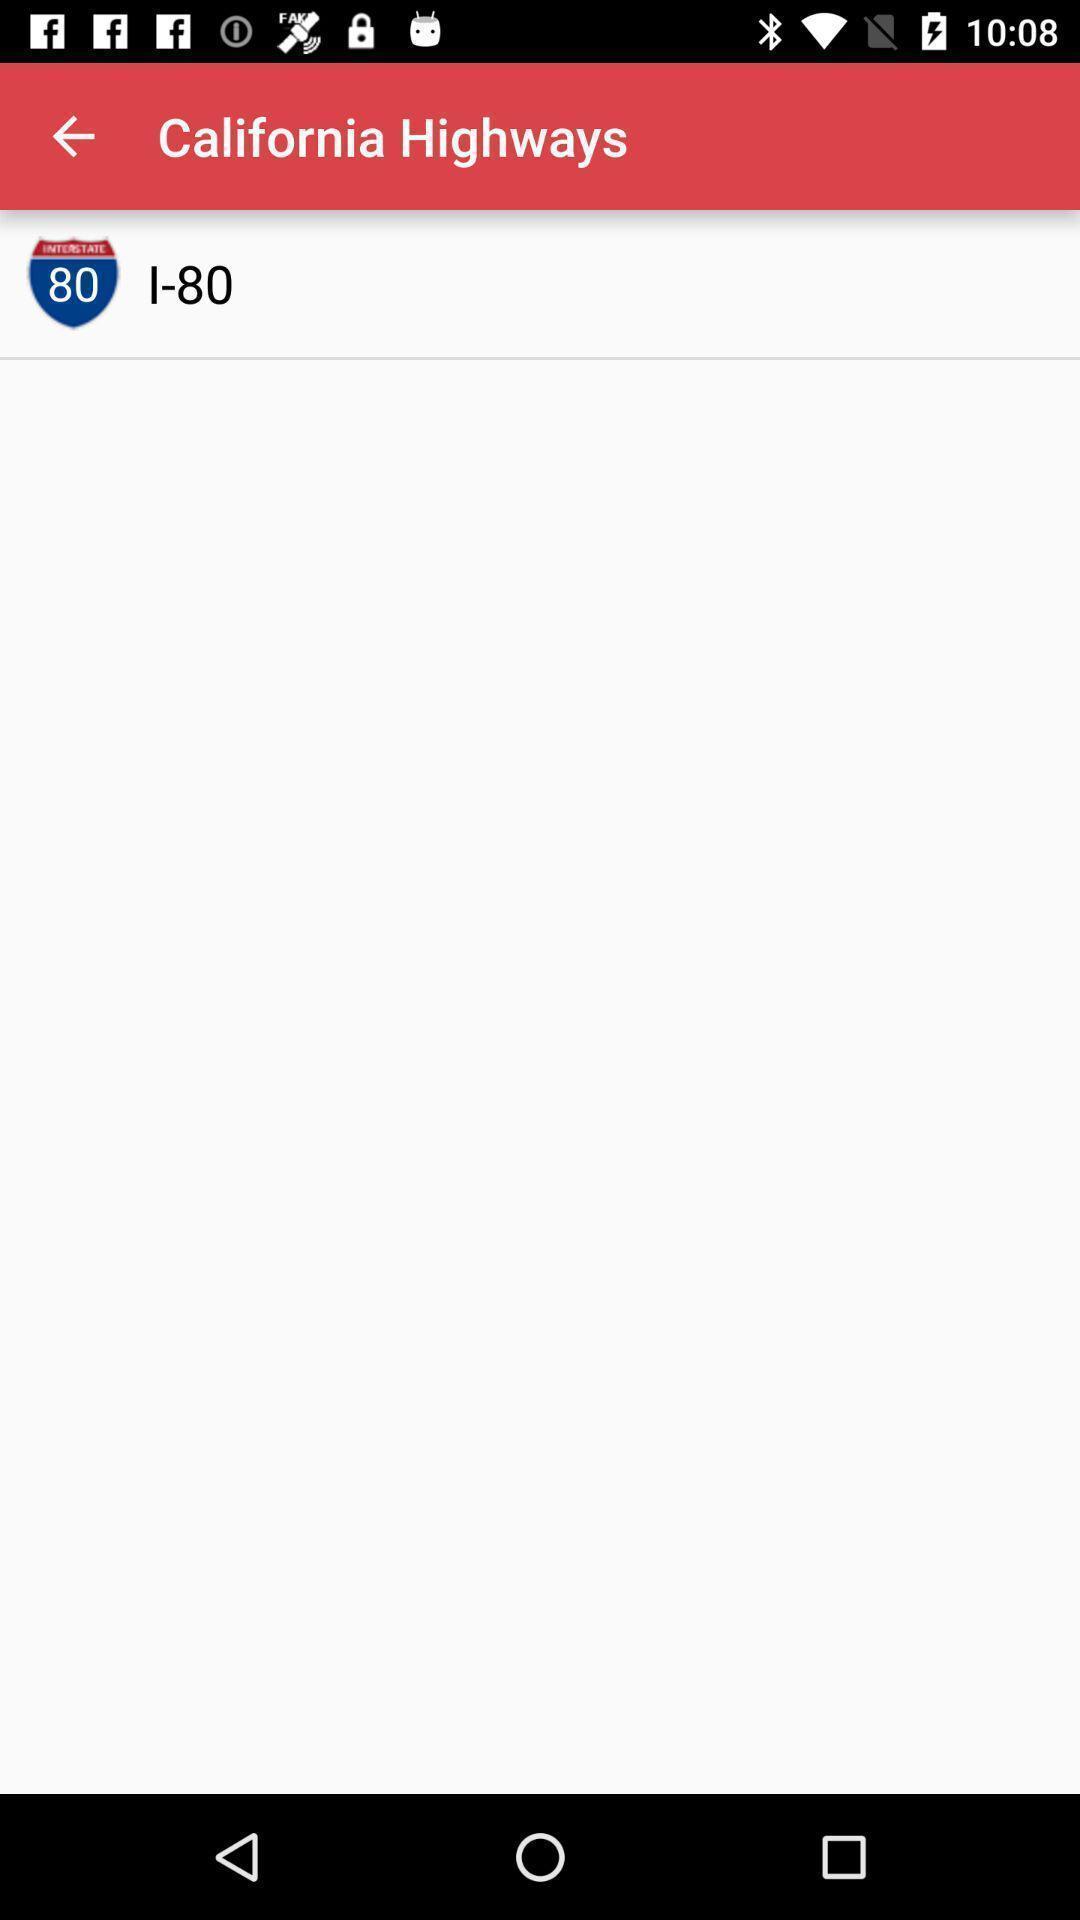Provide a description of this screenshot. Screen shows california highways. 